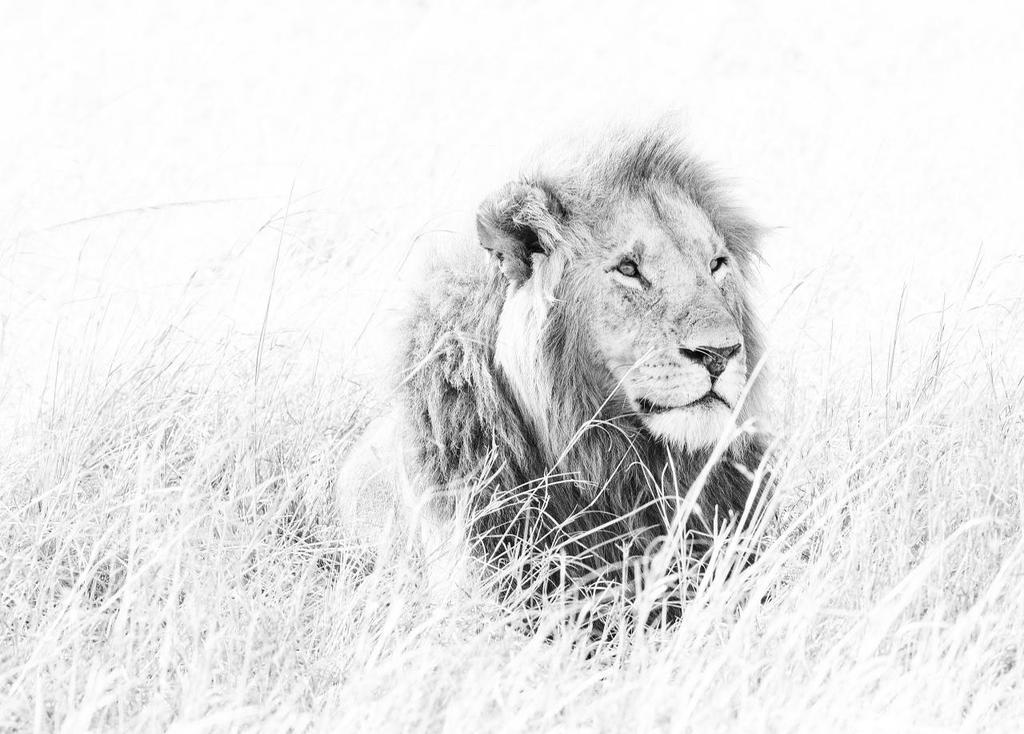What animal is present in the image? There is a lion in the image. What type of vegetation can be seen in the image? There is grass visible in the image. What type of pear is being used as a unit of measurement in the image? There is no pear or unit of measurement present in the image. What is the lion talking about in the image? Lions do not talk, so there is no conversation to be found in the image. 